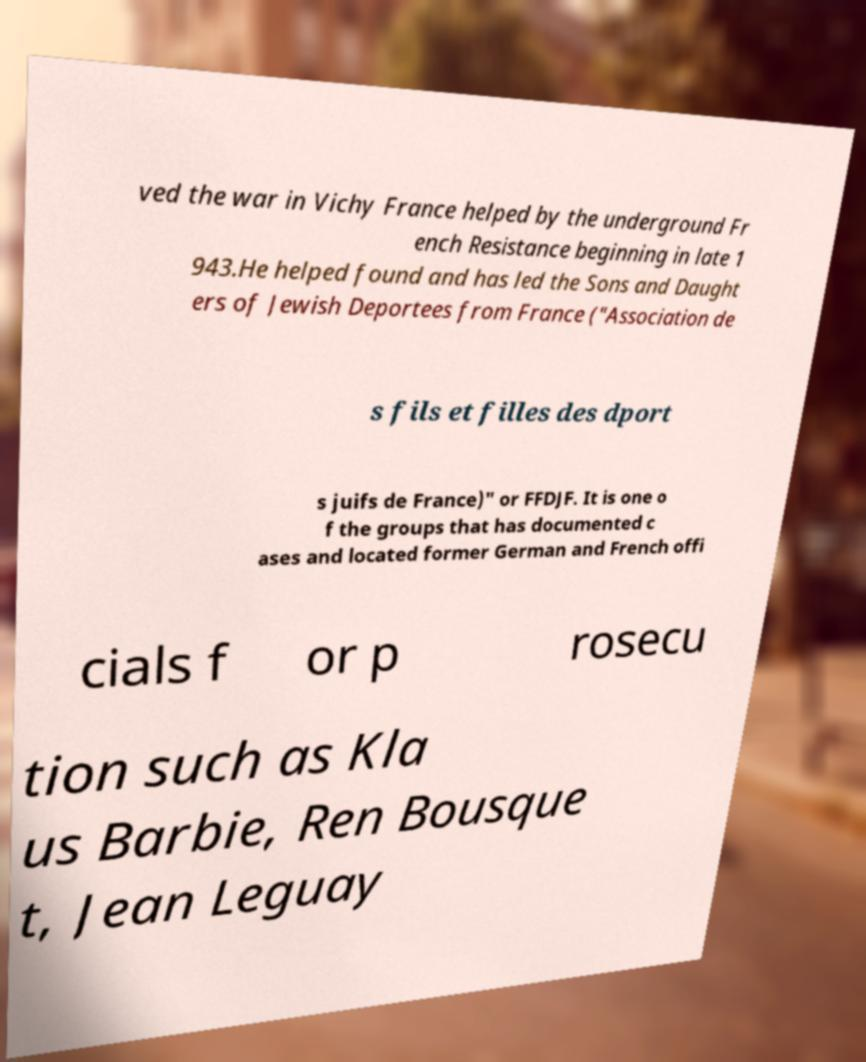Please read and relay the text visible in this image. What does it say? ved the war in Vichy France helped by the underground Fr ench Resistance beginning in late 1 943.He helped found and has led the Sons and Daught ers of Jewish Deportees from France ("Association de s fils et filles des dport s juifs de France)" or FFDJF. It is one o f the groups that has documented c ases and located former German and French offi cials f or p rosecu tion such as Kla us Barbie, Ren Bousque t, Jean Leguay 